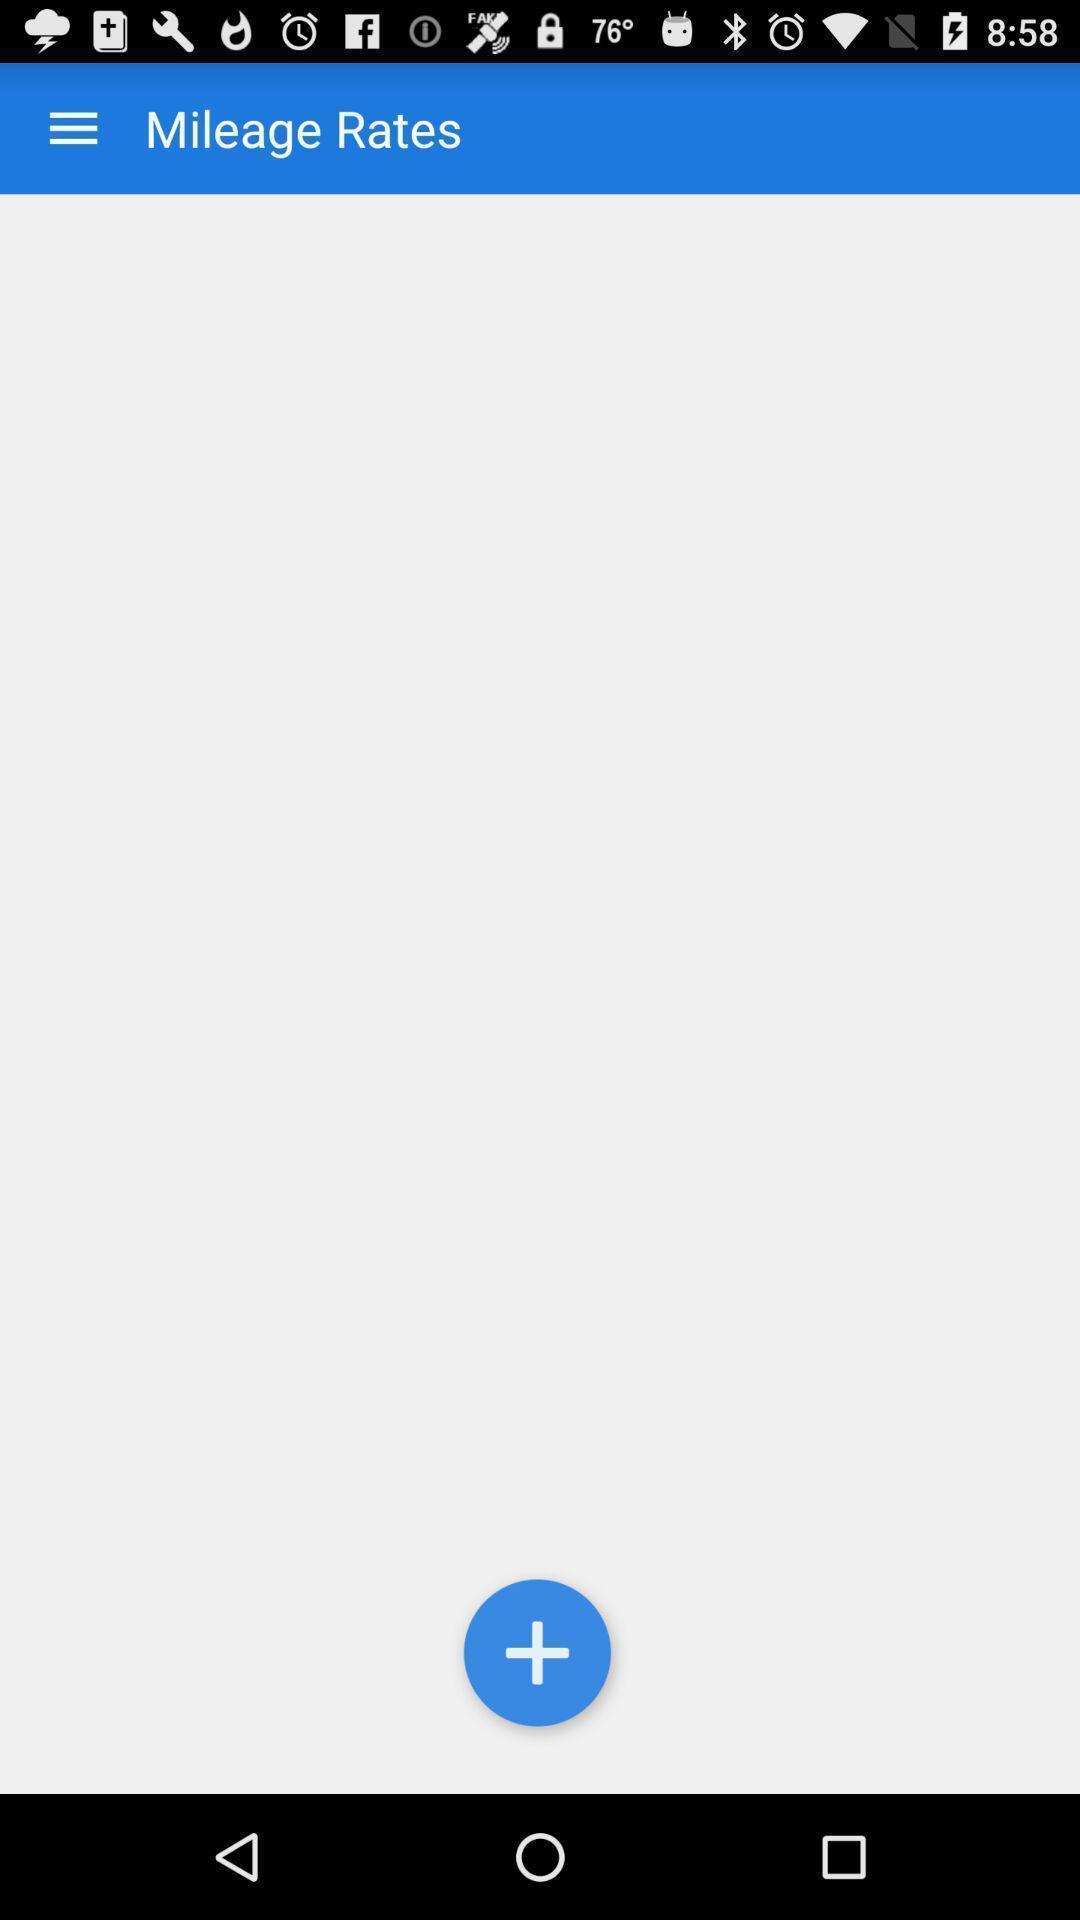Describe the key features of this screenshot. Page displaying the rates. 